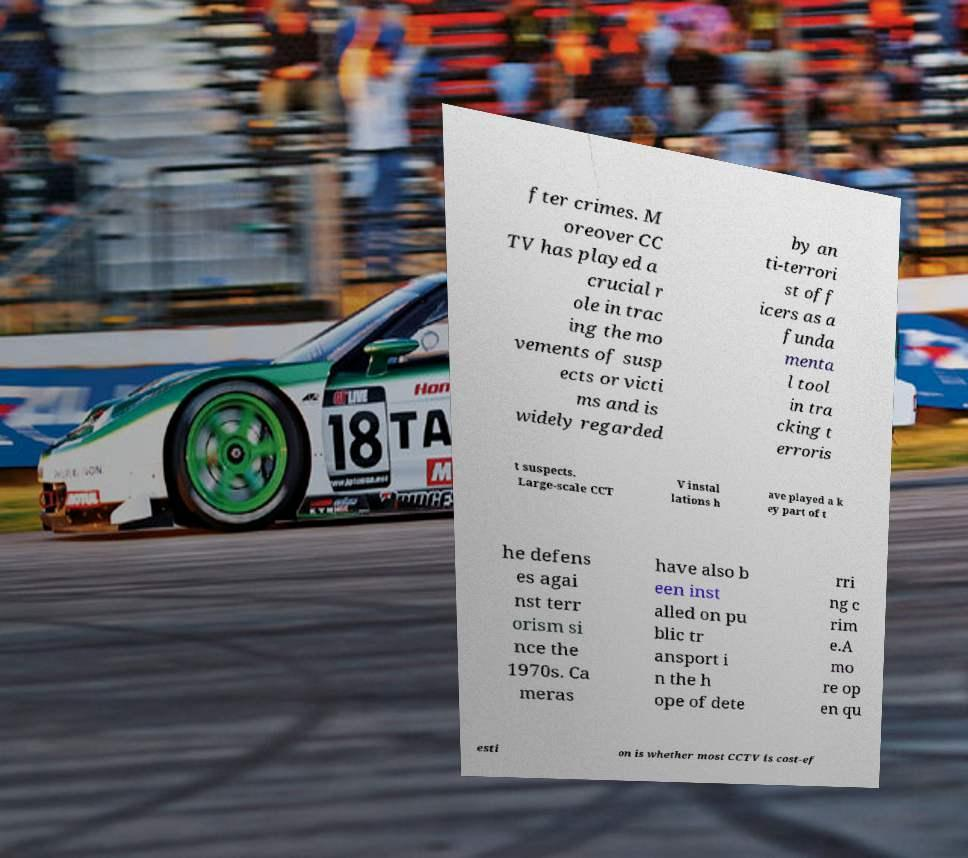For documentation purposes, I need the text within this image transcribed. Could you provide that? fter crimes. M oreover CC TV has played a crucial r ole in trac ing the mo vements of susp ects or victi ms and is widely regarded by an ti-terrori st off icers as a funda menta l tool in tra cking t erroris t suspects. Large-scale CCT V instal lations h ave played a k ey part of t he defens es agai nst terr orism si nce the 1970s. Ca meras have also b een inst alled on pu blic tr ansport i n the h ope of dete rri ng c rim e.A mo re op en qu esti on is whether most CCTV is cost-ef 